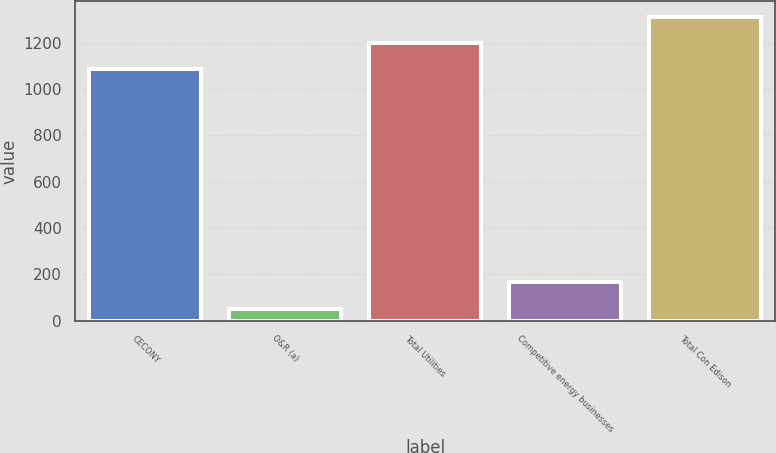Convert chart to OTSL. <chart><loc_0><loc_0><loc_500><loc_500><bar_chart><fcel>CECONY<fcel>O&R (a)<fcel>Total Utilities<fcel>Competitive energy businesses<fcel>Total Con Edison<nl><fcel>1084<fcel>52<fcel>1198.1<fcel>166.1<fcel>1312.2<nl></chart> 